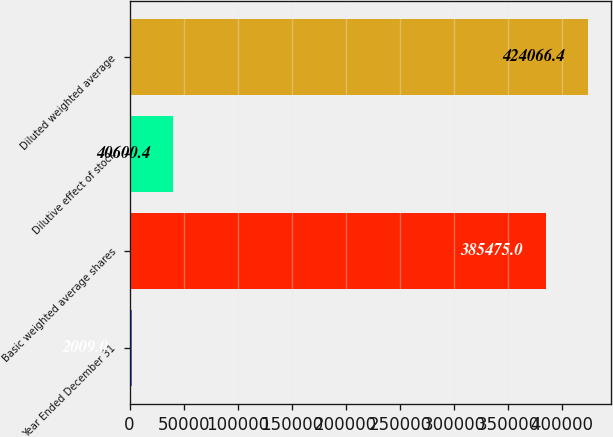Convert chart to OTSL. <chart><loc_0><loc_0><loc_500><loc_500><bar_chart><fcel>Year Ended December 31<fcel>Basic weighted average shares<fcel>Dilutive effect of stock<fcel>Diluted weighted average<nl><fcel>2009<fcel>385475<fcel>40600.4<fcel>424066<nl></chart> 